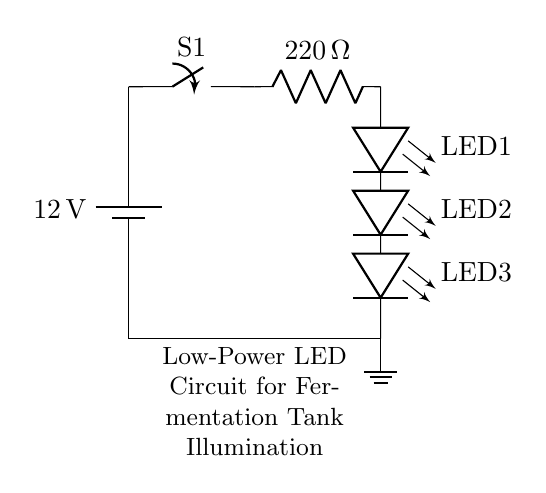What is the voltage of this circuit? The voltage is 12 volts, represented by the battery symbol in the circuit at the start. It shows the power supply voltage.
Answer: 12 volts How many LEDs are in the circuit? There are three LEDs in the circuit; they are labeled as LED1, LED2, and LED3 in the diagram.
Answer: Three What is the resistance value of the resistor? The resistance value of the resistor is 220 ohms, indicated beside the resistor symbol in the circuit diagram.
Answer: 220 ohms What type of circuit is this? This is a low-power LED lighting circuit, as evidenced by the usage of LEDs and the power supply meant for low-energy consumption.
Answer: Low-power LED lighting circuit What is the purpose of the switch in this circuit? The purpose of the switch is to control the flow of electricity, allowing the user to turn the LED lights on or off. It's positioned before the resistor in the circuit.
Answer: To control electricity flow What happens if the resistor value is decreased? If the resistor value is decreased, more current will flow through the circuit, which may cause the LEDs to burn out due to excess current beyond their rated capacity.
Answer: LEDs may burn out Why is a current limiting resistor necessary in this circuit? A current limiting resistor is necessary to protect the LEDs from excess current, ensuring they operate safely within their rated current levels to avoid damage.
Answer: To protect the LEDs 